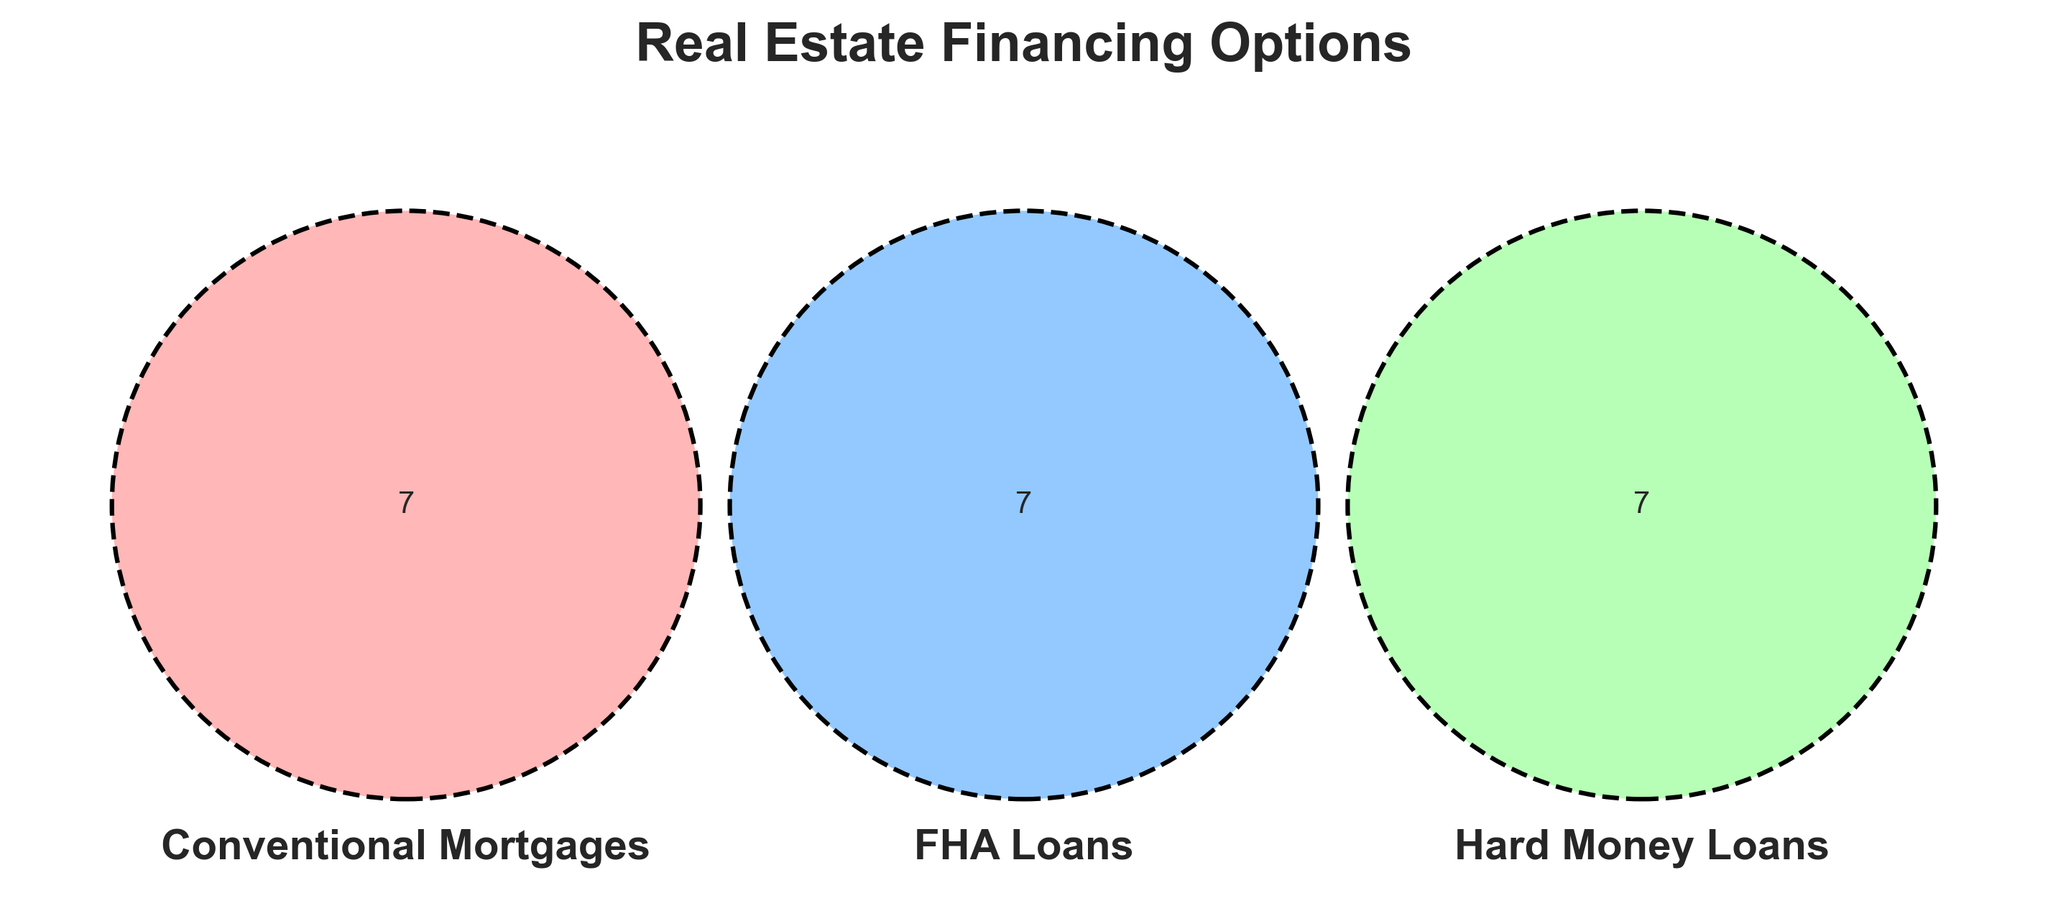What are the three types of real estate financing options shown in the diagram? The Venn diagram has labels for three sets which represent different financing options for real estate. These labels are "Conventional Mortgages," "FHA Loans," and "Hard Money Loans."
Answer: Conventional Mortgages, FHA Loans, Hard Money Loans Which financing option offers a low down payment? The section labeled "Low down payment" falls within the circle for "FHA Loans."
Answer: FHA Loans Which financing options are suitable for primary residences? The label "Primary residences" is within the "Conventional Mortgages" circle.
Answer: Conventional Mortgages What are the two financing options that have renovation loans? The label "Renovation loans" is within the "FHA Loans" circle.
Answer: FHA Loans Which financing option does not require mortgage insurance? The label "Mortgage insurance" is within the circle for "FHA Loans," suggesting that this option requires it, while others do not.
Answer: Conventional Mortgages, Hard Money Loans Which financing options provide long-term plans? The label "Long-term" is within the "Conventional Mortgages" circle.
Answer: Conventional Mortgages Which financing option has the shortest approval time? The label "Quick approval" is within the "Hard Money Loans" circle, indicating this type has the shortest approval time.
Answer: Hard Money Loans Between FHA Loans and Conventional Mortgages, which one is designed for first-time buyers? The label "First-time buyers" is found only within the "FHA Loans" circle.
Answer: FHA Loans Which options have high interest rates? The label "High interest" is in the circle for "Hard Money Loans."
Answer: Hard Money Loans Are there any financing options that require a down payment of 20%? The label "20% down" is in the "Conventional Mortgages" circle.
Answer: Conventional Mortgages 